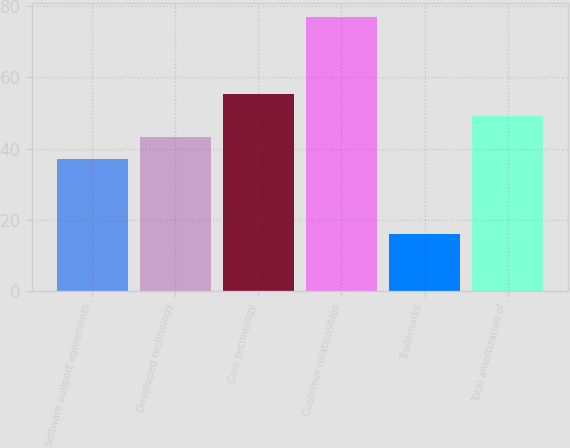Convert chart. <chart><loc_0><loc_0><loc_500><loc_500><bar_chart><fcel>Software support agreements<fcel>Developed technology<fcel>Core technology<fcel>Customer relationships<fcel>Trademarks<fcel>Total amortization of<nl><fcel>37<fcel>43.1<fcel>55.3<fcel>77<fcel>16<fcel>49.2<nl></chart> 